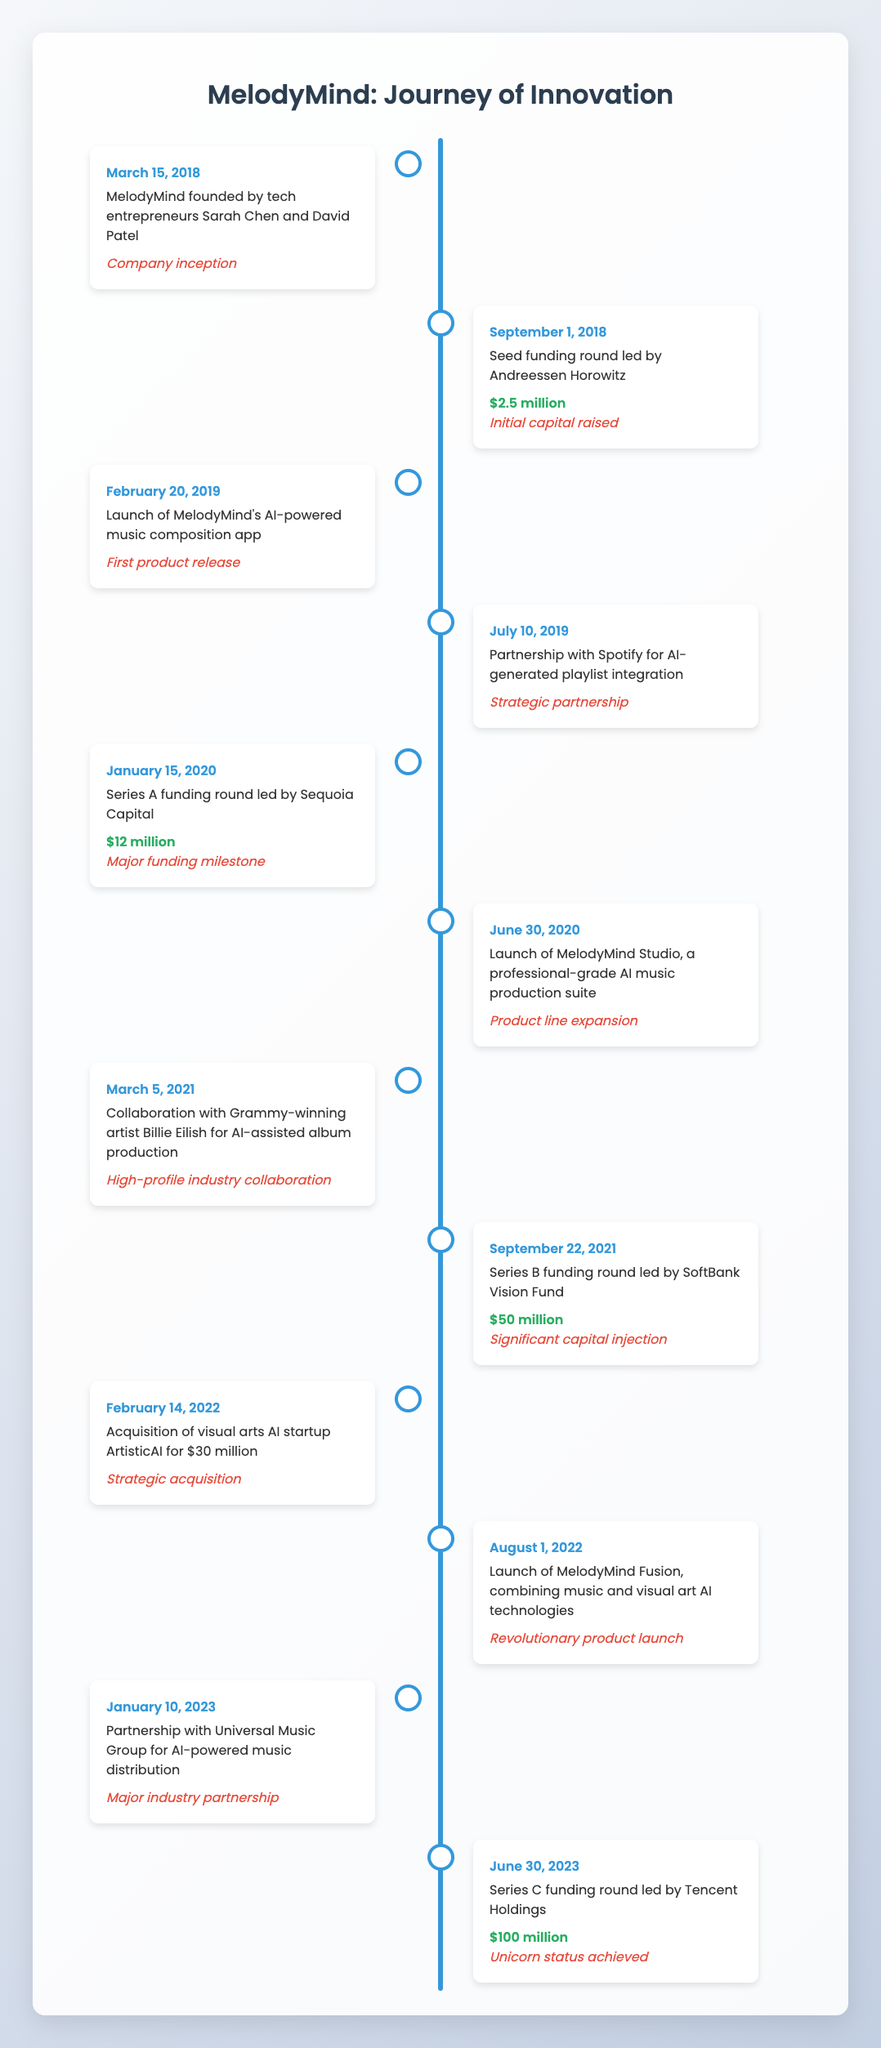What was the total capital raised by MelodyMind from its funding rounds? To find the total capital raised, we need to look at the funding amounts from the Series A, Series B, and Series C funding rounds. The amounts are: Series A - 12 million, Series B - 50 million, and Series C - 100 million. Adding these gives us: 12 + 50 + 100 = 162 million.
Answer: 162 million What milestone was achieved on June 30, 2023? The event that occurred on June 30, 2023, is Series C funding round led by Tencent Holdings, and the milestone is 'Unicorn status achieved.'
Answer: Unicorn status achieved Which event marked the first product release by MelodyMind? The first product release event is the launch of MelodyMind's AI-powered music composition app, which took place on February 20, 2019.
Answer: Launch of MelodyMind's AI-powered music composition app Did MelodyMind have any funding rounds in 2018? Yes, there was a seed funding round led by Andreessen Horowitz in 2018, which raised 2.5 million.
Answer: Yes What was the percentage increase in funding from Series A to Series B? Series A received 12 million, and Series B received 50 million. The increase in funding is 50 million - 12 million = 38 million. To calculate the percentage increase: (38/12) * 100 = 316.67%.
Answer: 316.67% Which strategic partnership occurred before the first product release? The partnership with Spotify for AI-generated playlist integration happened on July 10, 2019, which is after the first product release on February 20, 2019, so there was no strategic partnership before that event.
Answer: No How many major funding milestones does the timeline include? The timeline includes three major funding milestones: Series A ($12 million), Series B ($50 million), and Series C ($100 million).
Answer: Three What was the event on February 14, 2022, associated with? The event on February 14, 2022, was the acquisition of visual arts AI startup ArtisticAI for $30 million, and this event is categorized as a 'Strategic acquisition.'
Answer: Strategic acquisition What indicates that MelodyMind achieved unicorn status and when did this happen? MelodyMind achieved unicorn status during the Series C funding round led by Tencent Holdings, which occurred on June 30, 2023.
Answer: June 30, 2023 